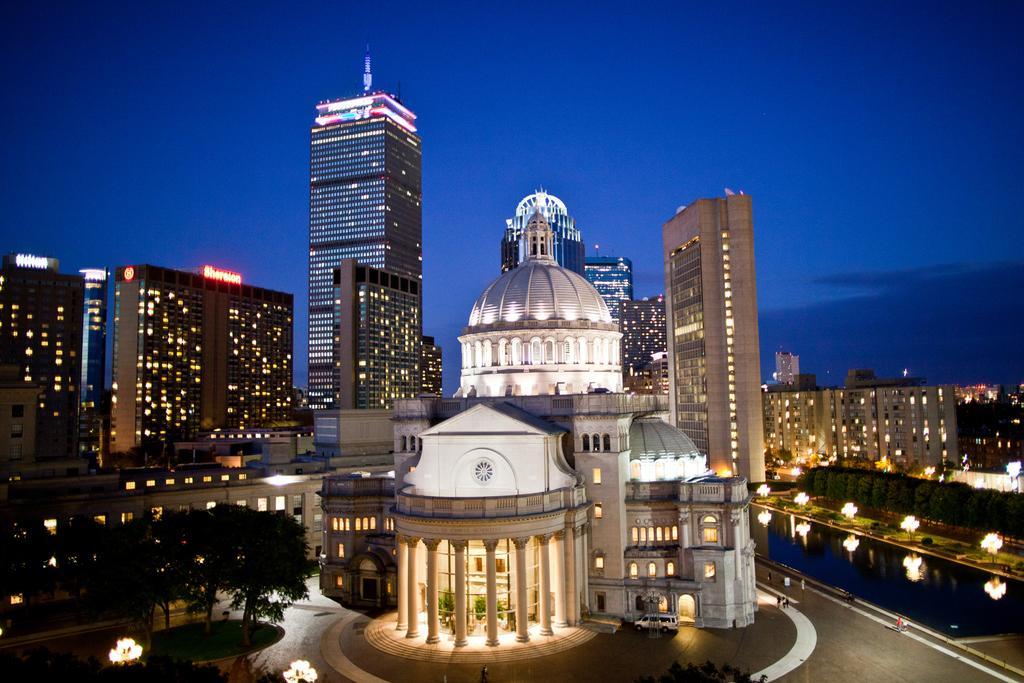Could you give a brief overview of what you see in this image? This is the picture of a city. In this image there are buildings and trees and there are street lights. At the top there is sky. At the bottom there is a vehicle on the road and there are group of people walking on the road and there is water and there is grass. 